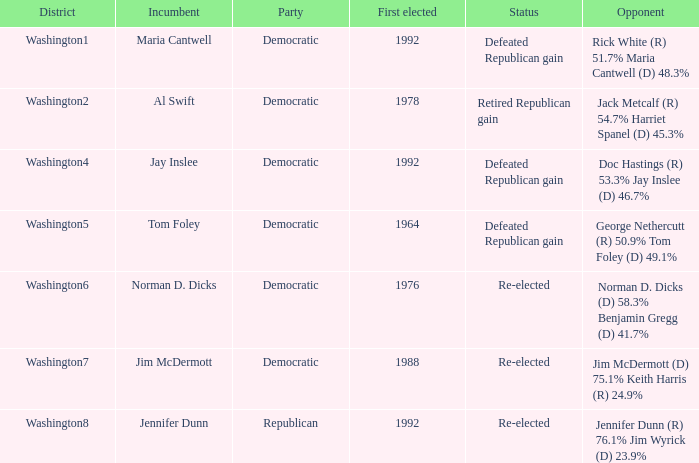7%? Defeated Republican gain. 